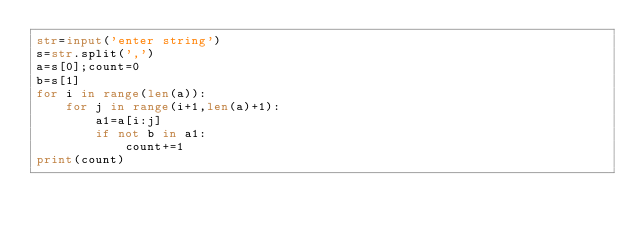<code> <loc_0><loc_0><loc_500><loc_500><_Python_>str=input('enter string')
s=str.split(',')
a=s[0];count=0
b=s[1]
for i in range(len(a)):
    for j in range(i+1,len(a)+1):
        a1=a[i:j]
        if not b in a1:
            count+=1
print(count)
    
</code> 